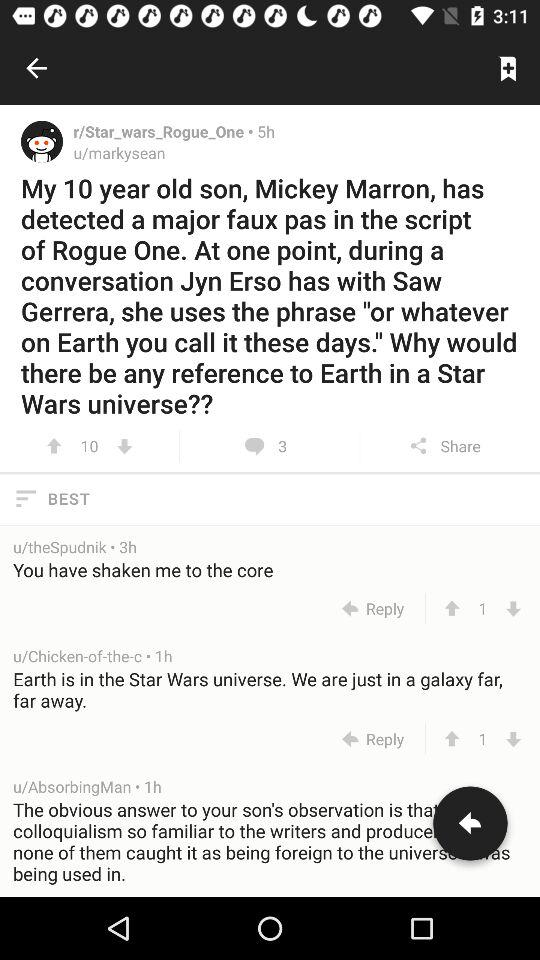When was the comment posted by "u/Chicken-of-the-c"? The comment was posted 1 hour ago. 